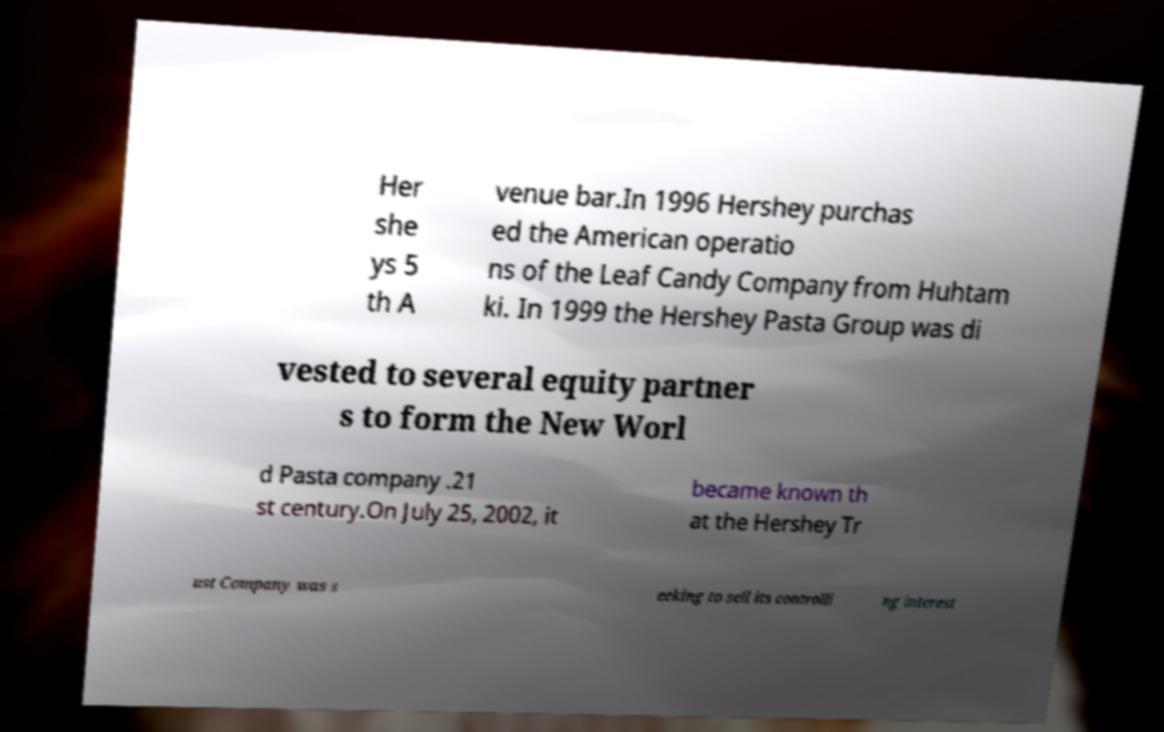Please identify and transcribe the text found in this image. Her she ys 5 th A venue bar.In 1996 Hershey purchas ed the American operatio ns of the Leaf Candy Company from Huhtam ki. In 1999 the Hershey Pasta Group was di vested to several equity partner s to form the New Worl d Pasta company .21 st century.On July 25, 2002, it became known th at the Hershey Tr ust Company was s eeking to sell its controlli ng interest 